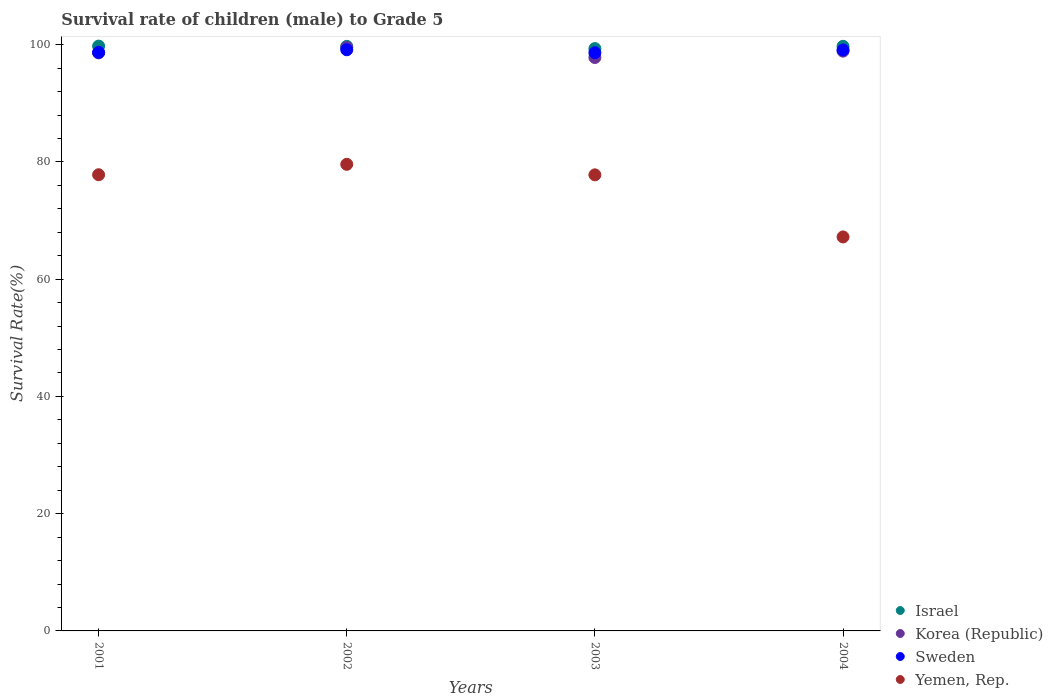How many different coloured dotlines are there?
Make the answer very short. 4. Is the number of dotlines equal to the number of legend labels?
Offer a very short reply. Yes. What is the survival rate of male children to grade 5 in Yemen, Rep. in 2001?
Your response must be concise. 77.81. Across all years, what is the maximum survival rate of male children to grade 5 in Sweden?
Your answer should be very brief. 99.13. Across all years, what is the minimum survival rate of male children to grade 5 in Korea (Republic)?
Keep it short and to the point. 97.81. In which year was the survival rate of male children to grade 5 in Israel maximum?
Your answer should be very brief. 2001. What is the total survival rate of male children to grade 5 in Korea (Republic) in the graph?
Keep it short and to the point. 394.82. What is the difference between the survival rate of male children to grade 5 in Sweden in 2002 and that in 2004?
Make the answer very short. 0.03. What is the difference between the survival rate of male children to grade 5 in Korea (Republic) in 2004 and the survival rate of male children to grade 5 in Yemen, Rep. in 2002?
Offer a very short reply. 19.31. What is the average survival rate of male children to grade 5 in Sweden per year?
Your answer should be very brief. 98.89. In the year 2003, what is the difference between the survival rate of male children to grade 5 in Israel and survival rate of male children to grade 5 in Sweden?
Your response must be concise. 0.71. In how many years, is the survival rate of male children to grade 5 in Yemen, Rep. greater than 80 %?
Keep it short and to the point. 0. What is the ratio of the survival rate of male children to grade 5 in Sweden in 2002 to that in 2003?
Keep it short and to the point. 1.01. Is the survival rate of male children to grade 5 in Korea (Republic) in 2003 less than that in 2004?
Keep it short and to the point. Yes. What is the difference between the highest and the second highest survival rate of male children to grade 5 in Korea (Republic)?
Offer a very short reply. 0.62. What is the difference between the highest and the lowest survival rate of male children to grade 5 in Korea (Republic)?
Make the answer very short. 1.7. In how many years, is the survival rate of male children to grade 5 in Korea (Republic) greater than the average survival rate of male children to grade 5 in Korea (Republic) taken over all years?
Your answer should be compact. 2. Is it the case that in every year, the sum of the survival rate of male children to grade 5 in Korea (Republic) and survival rate of male children to grade 5 in Israel  is greater than the sum of survival rate of male children to grade 5 in Yemen, Rep. and survival rate of male children to grade 5 in Sweden?
Offer a terse response. No. Does the survival rate of male children to grade 5 in Israel monotonically increase over the years?
Give a very brief answer. No. Is the survival rate of male children to grade 5 in Israel strictly greater than the survival rate of male children to grade 5 in Korea (Republic) over the years?
Your answer should be very brief. Yes. Is the survival rate of male children to grade 5 in Korea (Republic) strictly less than the survival rate of male children to grade 5 in Israel over the years?
Make the answer very short. Yes. What is the difference between two consecutive major ticks on the Y-axis?
Your response must be concise. 20. Does the graph contain grids?
Your answer should be compact. No. Where does the legend appear in the graph?
Make the answer very short. Bottom right. How many legend labels are there?
Provide a short and direct response. 4. What is the title of the graph?
Keep it short and to the point. Survival rate of children (male) to Grade 5. What is the label or title of the Y-axis?
Your answer should be compact. Survival Rate(%). What is the Survival Rate(%) in Israel in 2001?
Make the answer very short. 99.75. What is the Survival Rate(%) in Korea (Republic) in 2001?
Your answer should be very brief. 98.6. What is the Survival Rate(%) of Sweden in 2001?
Give a very brief answer. 98.69. What is the Survival Rate(%) in Yemen, Rep. in 2001?
Offer a very short reply. 77.81. What is the Survival Rate(%) of Israel in 2002?
Provide a succinct answer. 99.71. What is the Survival Rate(%) in Korea (Republic) in 2002?
Ensure brevity in your answer.  99.51. What is the Survival Rate(%) in Sweden in 2002?
Your answer should be compact. 99.13. What is the Survival Rate(%) in Yemen, Rep. in 2002?
Ensure brevity in your answer.  79.59. What is the Survival Rate(%) of Israel in 2003?
Your answer should be very brief. 99.33. What is the Survival Rate(%) of Korea (Republic) in 2003?
Make the answer very short. 97.81. What is the Survival Rate(%) of Sweden in 2003?
Provide a short and direct response. 98.63. What is the Survival Rate(%) in Yemen, Rep. in 2003?
Offer a terse response. 77.79. What is the Survival Rate(%) of Israel in 2004?
Give a very brief answer. 99.72. What is the Survival Rate(%) in Korea (Republic) in 2004?
Give a very brief answer. 98.9. What is the Survival Rate(%) of Sweden in 2004?
Offer a terse response. 99.1. What is the Survival Rate(%) of Yemen, Rep. in 2004?
Keep it short and to the point. 67.2. Across all years, what is the maximum Survival Rate(%) in Israel?
Provide a short and direct response. 99.75. Across all years, what is the maximum Survival Rate(%) in Korea (Republic)?
Keep it short and to the point. 99.51. Across all years, what is the maximum Survival Rate(%) in Sweden?
Your answer should be very brief. 99.13. Across all years, what is the maximum Survival Rate(%) in Yemen, Rep.?
Your answer should be compact. 79.59. Across all years, what is the minimum Survival Rate(%) of Israel?
Offer a terse response. 99.33. Across all years, what is the minimum Survival Rate(%) in Korea (Republic)?
Give a very brief answer. 97.81. Across all years, what is the minimum Survival Rate(%) of Sweden?
Make the answer very short. 98.63. Across all years, what is the minimum Survival Rate(%) in Yemen, Rep.?
Your response must be concise. 67.2. What is the total Survival Rate(%) in Israel in the graph?
Your response must be concise. 398.51. What is the total Survival Rate(%) of Korea (Republic) in the graph?
Your response must be concise. 394.82. What is the total Survival Rate(%) in Sweden in the graph?
Offer a very short reply. 395.54. What is the total Survival Rate(%) in Yemen, Rep. in the graph?
Provide a succinct answer. 302.4. What is the difference between the Survival Rate(%) in Israel in 2001 and that in 2002?
Offer a very short reply. 0.05. What is the difference between the Survival Rate(%) of Korea (Republic) in 2001 and that in 2002?
Ensure brevity in your answer.  -0.91. What is the difference between the Survival Rate(%) in Sweden in 2001 and that in 2002?
Your answer should be very brief. -0.44. What is the difference between the Survival Rate(%) in Yemen, Rep. in 2001 and that in 2002?
Provide a short and direct response. -1.78. What is the difference between the Survival Rate(%) in Israel in 2001 and that in 2003?
Offer a very short reply. 0.42. What is the difference between the Survival Rate(%) of Korea (Republic) in 2001 and that in 2003?
Give a very brief answer. 0.79. What is the difference between the Survival Rate(%) in Sweden in 2001 and that in 2003?
Offer a very short reply. 0.06. What is the difference between the Survival Rate(%) in Yemen, Rep. in 2001 and that in 2003?
Make the answer very short. 0.02. What is the difference between the Survival Rate(%) in Israel in 2001 and that in 2004?
Provide a short and direct response. 0.04. What is the difference between the Survival Rate(%) in Korea (Republic) in 2001 and that in 2004?
Give a very brief answer. -0.3. What is the difference between the Survival Rate(%) of Sweden in 2001 and that in 2004?
Offer a very short reply. -0.41. What is the difference between the Survival Rate(%) in Yemen, Rep. in 2001 and that in 2004?
Keep it short and to the point. 10.61. What is the difference between the Survival Rate(%) in Israel in 2002 and that in 2003?
Keep it short and to the point. 0.37. What is the difference between the Survival Rate(%) in Korea (Republic) in 2002 and that in 2003?
Make the answer very short. 1.7. What is the difference between the Survival Rate(%) in Sweden in 2002 and that in 2003?
Keep it short and to the point. 0.5. What is the difference between the Survival Rate(%) of Yemen, Rep. in 2002 and that in 2003?
Keep it short and to the point. 1.8. What is the difference between the Survival Rate(%) of Israel in 2002 and that in 2004?
Your answer should be compact. -0.01. What is the difference between the Survival Rate(%) of Korea (Republic) in 2002 and that in 2004?
Give a very brief answer. 0.62. What is the difference between the Survival Rate(%) in Sweden in 2002 and that in 2004?
Offer a very short reply. 0.03. What is the difference between the Survival Rate(%) of Yemen, Rep. in 2002 and that in 2004?
Keep it short and to the point. 12.39. What is the difference between the Survival Rate(%) in Israel in 2003 and that in 2004?
Your answer should be very brief. -0.39. What is the difference between the Survival Rate(%) of Korea (Republic) in 2003 and that in 2004?
Your answer should be compact. -1.08. What is the difference between the Survival Rate(%) of Sweden in 2003 and that in 2004?
Your response must be concise. -0.48. What is the difference between the Survival Rate(%) of Yemen, Rep. in 2003 and that in 2004?
Your response must be concise. 10.59. What is the difference between the Survival Rate(%) of Israel in 2001 and the Survival Rate(%) of Korea (Republic) in 2002?
Give a very brief answer. 0.24. What is the difference between the Survival Rate(%) in Israel in 2001 and the Survival Rate(%) in Sweden in 2002?
Provide a short and direct response. 0.62. What is the difference between the Survival Rate(%) in Israel in 2001 and the Survival Rate(%) in Yemen, Rep. in 2002?
Offer a terse response. 20.16. What is the difference between the Survival Rate(%) of Korea (Republic) in 2001 and the Survival Rate(%) of Sweden in 2002?
Offer a terse response. -0.53. What is the difference between the Survival Rate(%) of Korea (Republic) in 2001 and the Survival Rate(%) of Yemen, Rep. in 2002?
Provide a short and direct response. 19.01. What is the difference between the Survival Rate(%) in Sweden in 2001 and the Survival Rate(%) in Yemen, Rep. in 2002?
Keep it short and to the point. 19.1. What is the difference between the Survival Rate(%) of Israel in 2001 and the Survival Rate(%) of Korea (Republic) in 2003?
Provide a succinct answer. 1.94. What is the difference between the Survival Rate(%) of Israel in 2001 and the Survival Rate(%) of Sweden in 2003?
Keep it short and to the point. 1.13. What is the difference between the Survival Rate(%) of Israel in 2001 and the Survival Rate(%) of Yemen, Rep. in 2003?
Your answer should be very brief. 21.96. What is the difference between the Survival Rate(%) of Korea (Republic) in 2001 and the Survival Rate(%) of Sweden in 2003?
Provide a succinct answer. -0.03. What is the difference between the Survival Rate(%) in Korea (Republic) in 2001 and the Survival Rate(%) in Yemen, Rep. in 2003?
Your answer should be compact. 20.81. What is the difference between the Survival Rate(%) of Sweden in 2001 and the Survival Rate(%) of Yemen, Rep. in 2003?
Make the answer very short. 20.89. What is the difference between the Survival Rate(%) of Israel in 2001 and the Survival Rate(%) of Korea (Republic) in 2004?
Your answer should be compact. 0.86. What is the difference between the Survival Rate(%) in Israel in 2001 and the Survival Rate(%) in Sweden in 2004?
Provide a short and direct response. 0.65. What is the difference between the Survival Rate(%) in Israel in 2001 and the Survival Rate(%) in Yemen, Rep. in 2004?
Provide a short and direct response. 32.55. What is the difference between the Survival Rate(%) of Korea (Republic) in 2001 and the Survival Rate(%) of Sweden in 2004?
Make the answer very short. -0.5. What is the difference between the Survival Rate(%) of Korea (Republic) in 2001 and the Survival Rate(%) of Yemen, Rep. in 2004?
Your answer should be compact. 31.4. What is the difference between the Survival Rate(%) of Sweden in 2001 and the Survival Rate(%) of Yemen, Rep. in 2004?
Give a very brief answer. 31.49. What is the difference between the Survival Rate(%) in Israel in 2002 and the Survival Rate(%) in Korea (Republic) in 2003?
Ensure brevity in your answer.  1.89. What is the difference between the Survival Rate(%) of Israel in 2002 and the Survival Rate(%) of Sweden in 2003?
Offer a terse response. 1.08. What is the difference between the Survival Rate(%) of Israel in 2002 and the Survival Rate(%) of Yemen, Rep. in 2003?
Your response must be concise. 21.91. What is the difference between the Survival Rate(%) of Korea (Republic) in 2002 and the Survival Rate(%) of Sweden in 2003?
Give a very brief answer. 0.89. What is the difference between the Survival Rate(%) in Korea (Republic) in 2002 and the Survival Rate(%) in Yemen, Rep. in 2003?
Offer a terse response. 21.72. What is the difference between the Survival Rate(%) in Sweden in 2002 and the Survival Rate(%) in Yemen, Rep. in 2003?
Offer a very short reply. 21.33. What is the difference between the Survival Rate(%) of Israel in 2002 and the Survival Rate(%) of Korea (Republic) in 2004?
Your answer should be very brief. 0.81. What is the difference between the Survival Rate(%) in Israel in 2002 and the Survival Rate(%) in Sweden in 2004?
Make the answer very short. 0.6. What is the difference between the Survival Rate(%) of Israel in 2002 and the Survival Rate(%) of Yemen, Rep. in 2004?
Give a very brief answer. 32.5. What is the difference between the Survival Rate(%) in Korea (Republic) in 2002 and the Survival Rate(%) in Sweden in 2004?
Keep it short and to the point. 0.41. What is the difference between the Survival Rate(%) in Korea (Republic) in 2002 and the Survival Rate(%) in Yemen, Rep. in 2004?
Your answer should be very brief. 32.31. What is the difference between the Survival Rate(%) in Sweden in 2002 and the Survival Rate(%) in Yemen, Rep. in 2004?
Your response must be concise. 31.93. What is the difference between the Survival Rate(%) of Israel in 2003 and the Survival Rate(%) of Korea (Republic) in 2004?
Provide a short and direct response. 0.44. What is the difference between the Survival Rate(%) of Israel in 2003 and the Survival Rate(%) of Sweden in 2004?
Your answer should be very brief. 0.23. What is the difference between the Survival Rate(%) of Israel in 2003 and the Survival Rate(%) of Yemen, Rep. in 2004?
Ensure brevity in your answer.  32.13. What is the difference between the Survival Rate(%) in Korea (Republic) in 2003 and the Survival Rate(%) in Sweden in 2004?
Ensure brevity in your answer.  -1.29. What is the difference between the Survival Rate(%) of Korea (Republic) in 2003 and the Survival Rate(%) of Yemen, Rep. in 2004?
Your answer should be very brief. 30.61. What is the difference between the Survival Rate(%) in Sweden in 2003 and the Survival Rate(%) in Yemen, Rep. in 2004?
Offer a terse response. 31.42. What is the average Survival Rate(%) in Israel per year?
Provide a short and direct response. 99.63. What is the average Survival Rate(%) in Korea (Republic) per year?
Offer a terse response. 98.71. What is the average Survival Rate(%) of Sweden per year?
Provide a succinct answer. 98.89. What is the average Survival Rate(%) in Yemen, Rep. per year?
Offer a very short reply. 75.6. In the year 2001, what is the difference between the Survival Rate(%) in Israel and Survival Rate(%) in Korea (Republic)?
Make the answer very short. 1.15. In the year 2001, what is the difference between the Survival Rate(%) of Israel and Survival Rate(%) of Sweden?
Your response must be concise. 1.06. In the year 2001, what is the difference between the Survival Rate(%) of Israel and Survival Rate(%) of Yemen, Rep.?
Provide a succinct answer. 21.94. In the year 2001, what is the difference between the Survival Rate(%) of Korea (Republic) and Survival Rate(%) of Sweden?
Your response must be concise. -0.09. In the year 2001, what is the difference between the Survival Rate(%) in Korea (Republic) and Survival Rate(%) in Yemen, Rep.?
Offer a very short reply. 20.79. In the year 2001, what is the difference between the Survival Rate(%) of Sweden and Survival Rate(%) of Yemen, Rep.?
Provide a succinct answer. 20.87. In the year 2002, what is the difference between the Survival Rate(%) of Israel and Survival Rate(%) of Korea (Republic)?
Give a very brief answer. 0.19. In the year 2002, what is the difference between the Survival Rate(%) in Israel and Survival Rate(%) in Sweden?
Give a very brief answer. 0.58. In the year 2002, what is the difference between the Survival Rate(%) in Israel and Survival Rate(%) in Yemen, Rep.?
Offer a very short reply. 20.12. In the year 2002, what is the difference between the Survival Rate(%) of Korea (Republic) and Survival Rate(%) of Sweden?
Make the answer very short. 0.39. In the year 2002, what is the difference between the Survival Rate(%) in Korea (Republic) and Survival Rate(%) in Yemen, Rep.?
Provide a short and direct response. 19.92. In the year 2002, what is the difference between the Survival Rate(%) of Sweden and Survival Rate(%) of Yemen, Rep.?
Your answer should be compact. 19.54. In the year 2003, what is the difference between the Survival Rate(%) of Israel and Survival Rate(%) of Korea (Republic)?
Give a very brief answer. 1.52. In the year 2003, what is the difference between the Survival Rate(%) in Israel and Survival Rate(%) in Sweden?
Offer a terse response. 0.7. In the year 2003, what is the difference between the Survival Rate(%) in Israel and Survival Rate(%) in Yemen, Rep.?
Offer a terse response. 21.54. In the year 2003, what is the difference between the Survival Rate(%) in Korea (Republic) and Survival Rate(%) in Sweden?
Ensure brevity in your answer.  -0.81. In the year 2003, what is the difference between the Survival Rate(%) in Korea (Republic) and Survival Rate(%) in Yemen, Rep.?
Give a very brief answer. 20.02. In the year 2003, what is the difference between the Survival Rate(%) of Sweden and Survival Rate(%) of Yemen, Rep.?
Offer a very short reply. 20.83. In the year 2004, what is the difference between the Survival Rate(%) of Israel and Survival Rate(%) of Korea (Republic)?
Provide a succinct answer. 0.82. In the year 2004, what is the difference between the Survival Rate(%) in Israel and Survival Rate(%) in Sweden?
Offer a very short reply. 0.61. In the year 2004, what is the difference between the Survival Rate(%) in Israel and Survival Rate(%) in Yemen, Rep.?
Offer a very short reply. 32.51. In the year 2004, what is the difference between the Survival Rate(%) in Korea (Republic) and Survival Rate(%) in Sweden?
Your response must be concise. -0.21. In the year 2004, what is the difference between the Survival Rate(%) in Korea (Republic) and Survival Rate(%) in Yemen, Rep.?
Your answer should be compact. 31.69. In the year 2004, what is the difference between the Survival Rate(%) of Sweden and Survival Rate(%) of Yemen, Rep.?
Ensure brevity in your answer.  31.9. What is the ratio of the Survival Rate(%) of Israel in 2001 to that in 2002?
Offer a terse response. 1. What is the ratio of the Survival Rate(%) in Korea (Republic) in 2001 to that in 2002?
Your response must be concise. 0.99. What is the ratio of the Survival Rate(%) in Sweden in 2001 to that in 2002?
Provide a succinct answer. 1. What is the ratio of the Survival Rate(%) in Yemen, Rep. in 2001 to that in 2002?
Ensure brevity in your answer.  0.98. What is the ratio of the Survival Rate(%) of Israel in 2001 to that in 2003?
Offer a very short reply. 1. What is the ratio of the Survival Rate(%) of Korea (Republic) in 2001 to that in 2003?
Give a very brief answer. 1.01. What is the ratio of the Survival Rate(%) of Sweden in 2001 to that in 2003?
Ensure brevity in your answer.  1. What is the ratio of the Survival Rate(%) in Yemen, Rep. in 2001 to that in 2003?
Your answer should be very brief. 1. What is the ratio of the Survival Rate(%) of Korea (Republic) in 2001 to that in 2004?
Your answer should be compact. 1. What is the ratio of the Survival Rate(%) in Yemen, Rep. in 2001 to that in 2004?
Your answer should be very brief. 1.16. What is the ratio of the Survival Rate(%) in Korea (Republic) in 2002 to that in 2003?
Your answer should be very brief. 1.02. What is the ratio of the Survival Rate(%) in Yemen, Rep. in 2002 to that in 2003?
Offer a terse response. 1.02. What is the ratio of the Survival Rate(%) in Israel in 2002 to that in 2004?
Provide a short and direct response. 1. What is the ratio of the Survival Rate(%) in Korea (Republic) in 2002 to that in 2004?
Your answer should be very brief. 1.01. What is the ratio of the Survival Rate(%) in Yemen, Rep. in 2002 to that in 2004?
Offer a very short reply. 1.18. What is the ratio of the Survival Rate(%) of Sweden in 2003 to that in 2004?
Offer a very short reply. 1. What is the ratio of the Survival Rate(%) in Yemen, Rep. in 2003 to that in 2004?
Offer a very short reply. 1.16. What is the difference between the highest and the second highest Survival Rate(%) in Israel?
Your answer should be very brief. 0.04. What is the difference between the highest and the second highest Survival Rate(%) of Korea (Republic)?
Ensure brevity in your answer.  0.62. What is the difference between the highest and the second highest Survival Rate(%) of Sweden?
Provide a short and direct response. 0.03. What is the difference between the highest and the second highest Survival Rate(%) of Yemen, Rep.?
Offer a terse response. 1.78. What is the difference between the highest and the lowest Survival Rate(%) in Israel?
Offer a very short reply. 0.42. What is the difference between the highest and the lowest Survival Rate(%) in Korea (Republic)?
Provide a succinct answer. 1.7. What is the difference between the highest and the lowest Survival Rate(%) of Sweden?
Provide a short and direct response. 0.5. What is the difference between the highest and the lowest Survival Rate(%) of Yemen, Rep.?
Provide a short and direct response. 12.39. 